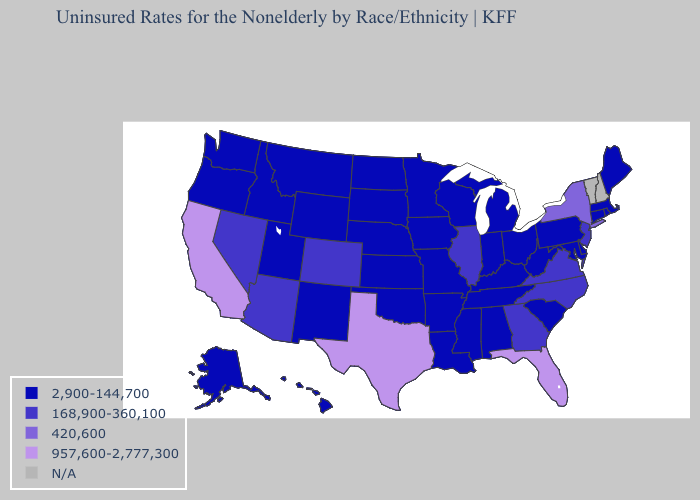What is the value of Tennessee?
Keep it brief. 2,900-144,700. What is the highest value in states that border Georgia?
Answer briefly. 957,600-2,777,300. What is the highest value in the USA?
Quick response, please. 957,600-2,777,300. Which states have the lowest value in the USA?
Keep it brief. Alabama, Alaska, Arkansas, Connecticut, Delaware, Hawaii, Idaho, Indiana, Iowa, Kansas, Kentucky, Louisiana, Maine, Maryland, Massachusetts, Michigan, Minnesota, Mississippi, Missouri, Montana, Nebraska, New Mexico, North Dakota, Ohio, Oklahoma, Oregon, Pennsylvania, Rhode Island, South Carolina, South Dakota, Tennessee, Utah, Washington, West Virginia, Wisconsin, Wyoming. Is the legend a continuous bar?
Be succinct. No. What is the value of Kentucky?
Concise answer only. 2,900-144,700. What is the highest value in states that border Florida?
Keep it brief. 168,900-360,100. Does the first symbol in the legend represent the smallest category?
Keep it brief. Yes. Does the map have missing data?
Write a very short answer. Yes. Does Florida have the highest value in the USA?
Quick response, please. Yes. Does South Dakota have the lowest value in the MidWest?
Be succinct. Yes. What is the highest value in the West ?
Be succinct. 957,600-2,777,300. Does Utah have the lowest value in the West?
Quick response, please. Yes. Which states hav the highest value in the West?
Give a very brief answer. California. 